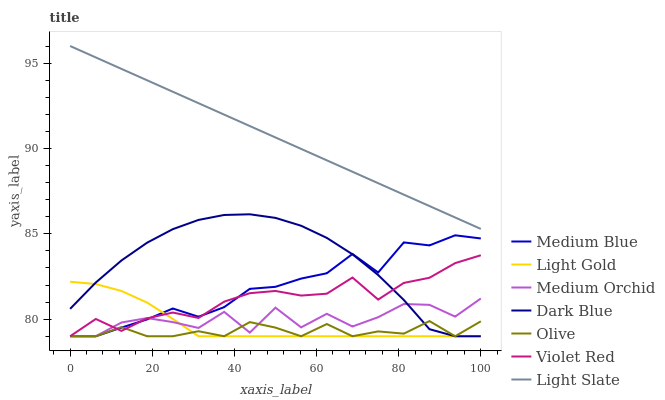Does Olive have the minimum area under the curve?
Answer yes or no. Yes. Does Light Slate have the maximum area under the curve?
Answer yes or no. Yes. Does Medium Orchid have the minimum area under the curve?
Answer yes or no. No. Does Medium Orchid have the maximum area under the curve?
Answer yes or no. No. Is Light Slate the smoothest?
Answer yes or no. Yes. Is Medium Orchid the roughest?
Answer yes or no. Yes. Is Medium Orchid the smoothest?
Answer yes or no. No. Is Light Slate the roughest?
Answer yes or no. No. Does Violet Red have the lowest value?
Answer yes or no. Yes. Does Light Slate have the lowest value?
Answer yes or no. No. Does Light Slate have the highest value?
Answer yes or no. Yes. Does Medium Orchid have the highest value?
Answer yes or no. No. Is Medium Blue less than Light Slate?
Answer yes or no. Yes. Is Light Slate greater than Dark Blue?
Answer yes or no. Yes. Does Olive intersect Dark Blue?
Answer yes or no. Yes. Is Olive less than Dark Blue?
Answer yes or no. No. Is Olive greater than Dark Blue?
Answer yes or no. No. Does Medium Blue intersect Light Slate?
Answer yes or no. No. 